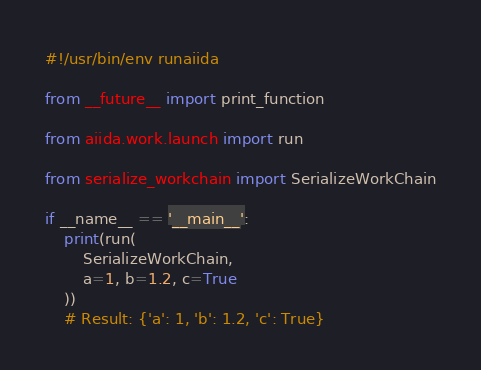Convert code to text. <code><loc_0><loc_0><loc_500><loc_500><_Python_>#!/usr/bin/env runaiida

from __future__ import print_function

from aiida.work.launch import run

from serialize_workchain import SerializeWorkChain

if __name__ == '__main__':
    print(run(
        SerializeWorkChain,
        a=1, b=1.2, c=True
    ))
    # Result: {'a': 1, 'b': 1.2, 'c': True}
</code> 